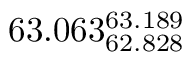Convert formula to latex. <formula><loc_0><loc_0><loc_500><loc_500>6 3 . 0 6 3 _ { 6 2 . 8 2 8 } ^ { 6 3 . 1 8 9 }</formula> 